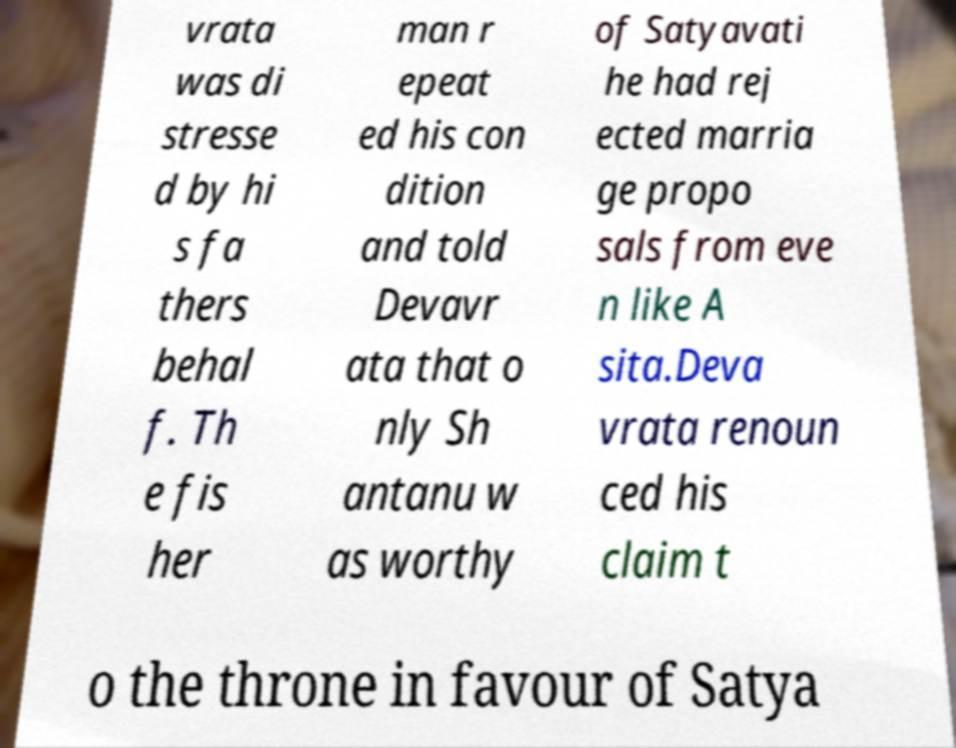What messages or text are displayed in this image? I need them in a readable, typed format. vrata was di stresse d by hi s fa thers behal f. Th e fis her man r epeat ed his con dition and told Devavr ata that o nly Sh antanu w as worthy of Satyavati he had rej ected marria ge propo sals from eve n like A sita.Deva vrata renoun ced his claim t o the throne in favour of Satya 